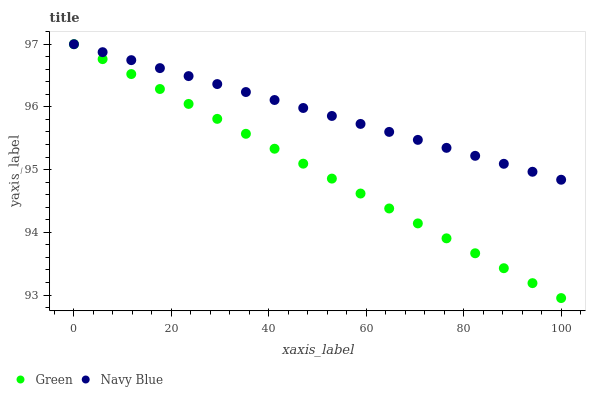Does Green have the minimum area under the curve?
Answer yes or no. Yes. Does Navy Blue have the maximum area under the curve?
Answer yes or no. Yes. Does Green have the maximum area under the curve?
Answer yes or no. No. Is Navy Blue the smoothest?
Answer yes or no. Yes. Is Green the roughest?
Answer yes or no. Yes. Is Green the smoothest?
Answer yes or no. No. Does Green have the lowest value?
Answer yes or no. Yes. Does Green have the highest value?
Answer yes or no. Yes. Does Green intersect Navy Blue?
Answer yes or no. Yes. Is Green less than Navy Blue?
Answer yes or no. No. Is Green greater than Navy Blue?
Answer yes or no. No. 